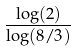<formula> <loc_0><loc_0><loc_500><loc_500>\frac { \log ( 2 ) } { \log ( 8 / 3 ) }</formula> 